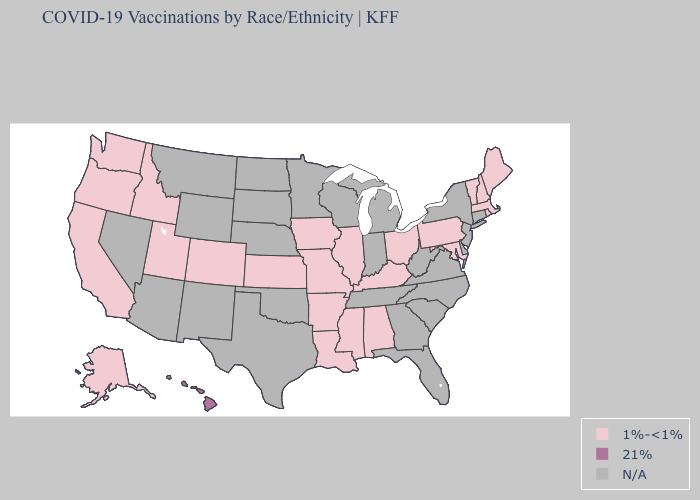What is the highest value in the Northeast ?
Answer briefly. 1%-<1%. Which states have the lowest value in the MidWest?
Keep it brief. Illinois, Iowa, Kansas, Missouri, Ohio. Which states have the lowest value in the USA?
Quick response, please. Alabama, Alaska, Arkansas, California, Colorado, Idaho, Illinois, Iowa, Kansas, Kentucky, Louisiana, Maine, Maryland, Massachusetts, Mississippi, Missouri, New Hampshire, Ohio, Oregon, Pennsylvania, Rhode Island, Utah, Vermont, Washington. What is the highest value in states that border Pennsylvania?
Keep it brief. 1%-<1%. Which states have the lowest value in the MidWest?
Short answer required. Illinois, Iowa, Kansas, Missouri, Ohio. What is the highest value in the USA?
Be succinct. 21%. What is the highest value in the USA?
Write a very short answer. 21%. What is the lowest value in the USA?
Keep it brief. 1%-<1%. Name the states that have a value in the range 1%-<1%?
Write a very short answer. Alabama, Alaska, Arkansas, California, Colorado, Idaho, Illinois, Iowa, Kansas, Kentucky, Louisiana, Maine, Maryland, Massachusetts, Mississippi, Missouri, New Hampshire, Ohio, Oregon, Pennsylvania, Rhode Island, Utah, Vermont, Washington. Name the states that have a value in the range 1%-<1%?
Short answer required. Alabama, Alaska, Arkansas, California, Colorado, Idaho, Illinois, Iowa, Kansas, Kentucky, Louisiana, Maine, Maryland, Massachusetts, Mississippi, Missouri, New Hampshire, Ohio, Oregon, Pennsylvania, Rhode Island, Utah, Vermont, Washington. What is the lowest value in the USA?
Quick response, please. 1%-<1%. What is the value of Texas?
Concise answer only. N/A. Does the first symbol in the legend represent the smallest category?
Keep it brief. Yes. 